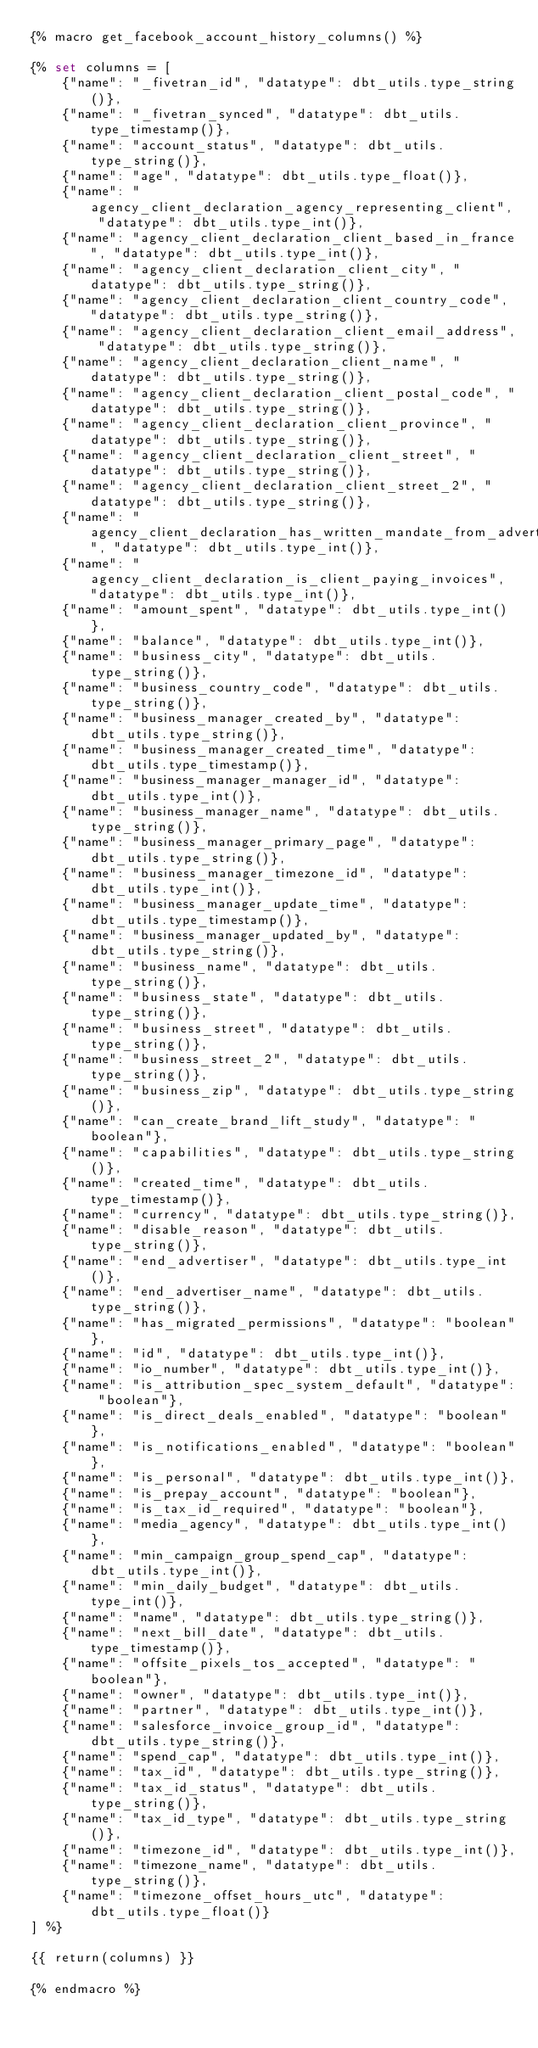<code> <loc_0><loc_0><loc_500><loc_500><_SQL_>{% macro get_facebook_account_history_columns() %}

{% set columns = [
    {"name": "_fivetran_id", "datatype": dbt_utils.type_string()},
    {"name": "_fivetran_synced", "datatype": dbt_utils.type_timestamp()},
    {"name": "account_status", "datatype": dbt_utils.type_string()},
    {"name": "age", "datatype": dbt_utils.type_float()},
    {"name": "agency_client_declaration_agency_representing_client", "datatype": dbt_utils.type_int()},
    {"name": "agency_client_declaration_client_based_in_france", "datatype": dbt_utils.type_int()},
    {"name": "agency_client_declaration_client_city", "datatype": dbt_utils.type_string()},
    {"name": "agency_client_declaration_client_country_code", "datatype": dbt_utils.type_string()},
    {"name": "agency_client_declaration_client_email_address", "datatype": dbt_utils.type_string()},
    {"name": "agency_client_declaration_client_name", "datatype": dbt_utils.type_string()},
    {"name": "agency_client_declaration_client_postal_code", "datatype": dbt_utils.type_string()},
    {"name": "agency_client_declaration_client_province", "datatype": dbt_utils.type_string()},
    {"name": "agency_client_declaration_client_street", "datatype": dbt_utils.type_string()},
    {"name": "agency_client_declaration_client_street_2", "datatype": dbt_utils.type_string()},
    {"name": "agency_client_declaration_has_written_mandate_from_advertiser", "datatype": dbt_utils.type_int()},
    {"name": "agency_client_declaration_is_client_paying_invoices", "datatype": dbt_utils.type_int()},
    {"name": "amount_spent", "datatype": dbt_utils.type_int()},
    {"name": "balance", "datatype": dbt_utils.type_int()},
    {"name": "business_city", "datatype": dbt_utils.type_string()},
    {"name": "business_country_code", "datatype": dbt_utils.type_string()},
    {"name": "business_manager_created_by", "datatype": dbt_utils.type_string()},
    {"name": "business_manager_created_time", "datatype": dbt_utils.type_timestamp()},
    {"name": "business_manager_manager_id", "datatype": dbt_utils.type_int()},
    {"name": "business_manager_name", "datatype": dbt_utils.type_string()},
    {"name": "business_manager_primary_page", "datatype": dbt_utils.type_string()},
    {"name": "business_manager_timezone_id", "datatype": dbt_utils.type_int()},
    {"name": "business_manager_update_time", "datatype": dbt_utils.type_timestamp()},
    {"name": "business_manager_updated_by", "datatype": dbt_utils.type_string()},
    {"name": "business_name", "datatype": dbt_utils.type_string()},
    {"name": "business_state", "datatype": dbt_utils.type_string()},
    {"name": "business_street", "datatype": dbt_utils.type_string()},
    {"name": "business_street_2", "datatype": dbt_utils.type_string()},
    {"name": "business_zip", "datatype": dbt_utils.type_string()},
    {"name": "can_create_brand_lift_study", "datatype": "boolean"},
    {"name": "capabilities", "datatype": dbt_utils.type_string()},
    {"name": "created_time", "datatype": dbt_utils.type_timestamp()},
    {"name": "currency", "datatype": dbt_utils.type_string()},
    {"name": "disable_reason", "datatype": dbt_utils.type_string()},
    {"name": "end_advertiser", "datatype": dbt_utils.type_int()},
    {"name": "end_advertiser_name", "datatype": dbt_utils.type_string()},
    {"name": "has_migrated_permissions", "datatype": "boolean"},
    {"name": "id", "datatype": dbt_utils.type_int()},
    {"name": "io_number", "datatype": dbt_utils.type_int()},
    {"name": "is_attribution_spec_system_default", "datatype": "boolean"},
    {"name": "is_direct_deals_enabled", "datatype": "boolean"},
    {"name": "is_notifications_enabled", "datatype": "boolean"},
    {"name": "is_personal", "datatype": dbt_utils.type_int()},
    {"name": "is_prepay_account", "datatype": "boolean"},
    {"name": "is_tax_id_required", "datatype": "boolean"},
    {"name": "media_agency", "datatype": dbt_utils.type_int()},
    {"name": "min_campaign_group_spend_cap", "datatype": dbt_utils.type_int()},
    {"name": "min_daily_budget", "datatype": dbt_utils.type_int()},
    {"name": "name", "datatype": dbt_utils.type_string()},
    {"name": "next_bill_date", "datatype": dbt_utils.type_timestamp()},
    {"name": "offsite_pixels_tos_accepted", "datatype": "boolean"},
    {"name": "owner", "datatype": dbt_utils.type_int()},
    {"name": "partner", "datatype": dbt_utils.type_int()},
    {"name": "salesforce_invoice_group_id", "datatype": dbt_utils.type_string()},
    {"name": "spend_cap", "datatype": dbt_utils.type_int()},
    {"name": "tax_id", "datatype": dbt_utils.type_string()},
    {"name": "tax_id_status", "datatype": dbt_utils.type_string()},
    {"name": "tax_id_type", "datatype": dbt_utils.type_string()},
    {"name": "timezone_id", "datatype": dbt_utils.type_int()},
    {"name": "timezone_name", "datatype": dbt_utils.type_string()},
    {"name": "timezone_offset_hours_utc", "datatype": dbt_utils.type_float()}
] %}

{{ return(columns) }}

{% endmacro %}
</code> 